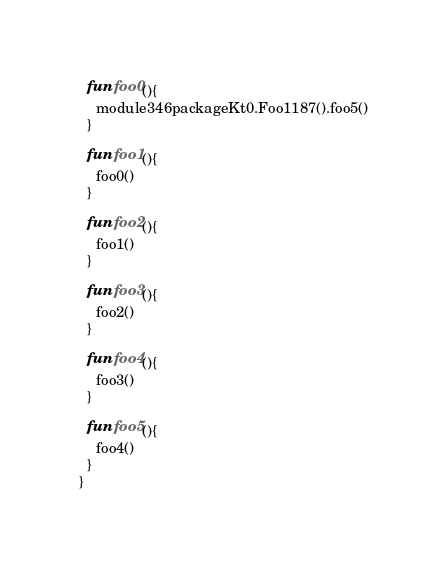Convert code to text. <code><loc_0><loc_0><loc_500><loc_500><_Kotlin_>  fun foo0(){
    module346packageKt0.Foo1187().foo5()
  }

  fun foo1(){
    foo0()
  }

  fun foo2(){
    foo1()
  }

  fun foo3(){
    foo2()
  }

  fun foo4(){
    foo3()
  }

  fun foo5(){
    foo4()
  }
}</code> 